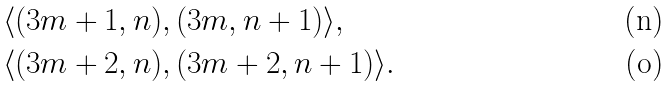Convert formula to latex. <formula><loc_0><loc_0><loc_500><loc_500>& \langle ( 3 m + 1 , n ) , ( 3 m , n + 1 ) \rangle , \\ & \langle ( 3 m + 2 , n ) , ( 3 m + 2 , n + 1 ) \rangle .</formula> 